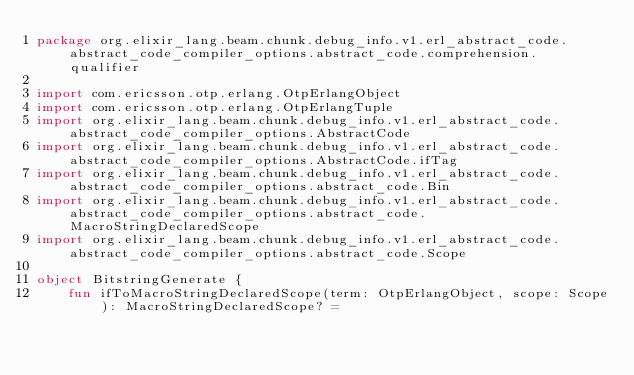<code> <loc_0><loc_0><loc_500><loc_500><_Kotlin_>package org.elixir_lang.beam.chunk.debug_info.v1.erl_abstract_code.abstract_code_compiler_options.abstract_code.comprehension.qualifier

import com.ericsson.otp.erlang.OtpErlangObject
import com.ericsson.otp.erlang.OtpErlangTuple
import org.elixir_lang.beam.chunk.debug_info.v1.erl_abstract_code.abstract_code_compiler_options.AbstractCode
import org.elixir_lang.beam.chunk.debug_info.v1.erl_abstract_code.abstract_code_compiler_options.AbstractCode.ifTag
import org.elixir_lang.beam.chunk.debug_info.v1.erl_abstract_code.abstract_code_compiler_options.abstract_code.Bin
import org.elixir_lang.beam.chunk.debug_info.v1.erl_abstract_code.abstract_code_compiler_options.abstract_code.MacroStringDeclaredScope
import org.elixir_lang.beam.chunk.debug_info.v1.erl_abstract_code.abstract_code_compiler_options.abstract_code.Scope

object BitstringGenerate {
    fun ifToMacroStringDeclaredScope(term: OtpErlangObject, scope: Scope): MacroStringDeclaredScope? =</code> 